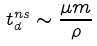<formula> <loc_0><loc_0><loc_500><loc_500>t _ { d } ^ { n s } \sim \frac { \mu m } { \rho }</formula> 